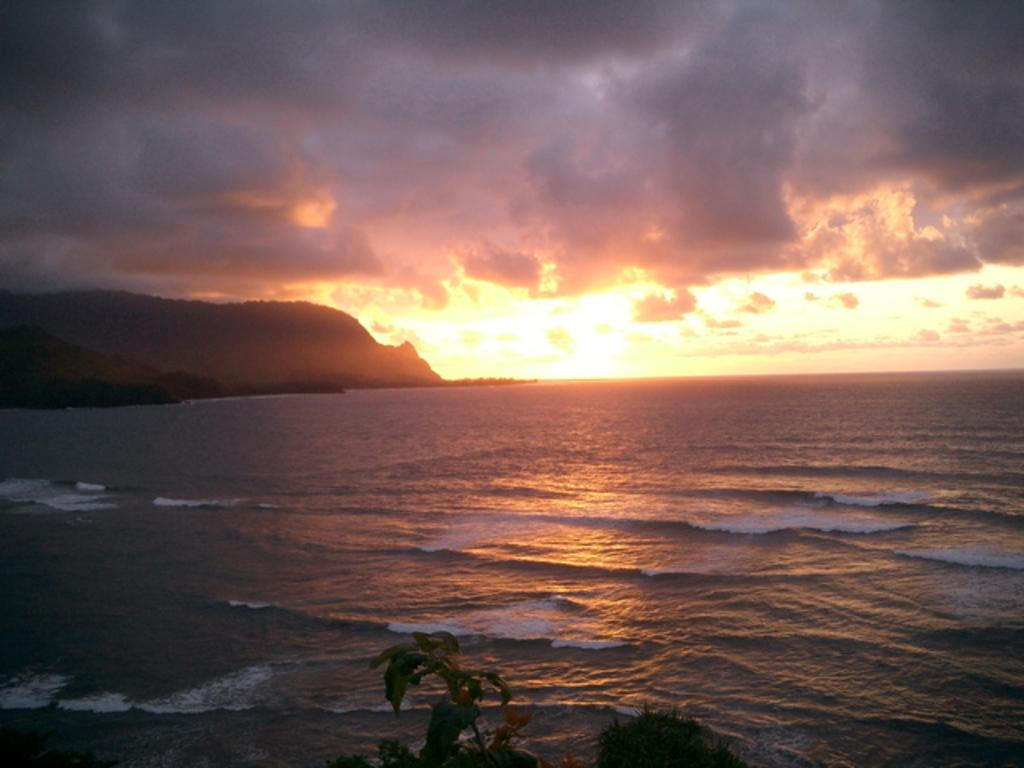What is located in the front of the image? There is a plant in the front of the image. What can be seen in the background of the image? There is an ocean and mountains in the background of the image. What is the condition of the sky in the image? The sky is cloudy in the image. How many roses can be seen growing on the trees in the image? There are no roses or trees present in the image; it features a plant, an ocean, mountains, and a cloudy sky. 